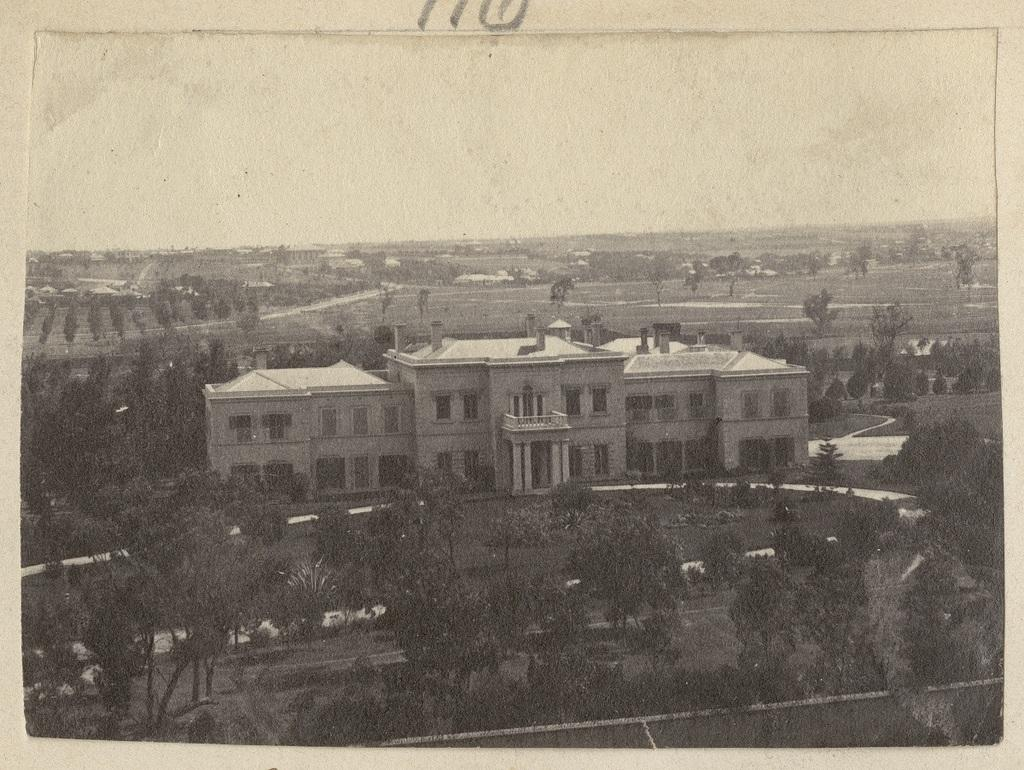What is the main subject of the image? The main subject of the image is a photo of a building. What type of natural elements can be seen in the image? There are trees and grass in the image. What man-made feature is present in the image? There is a road in the image. What part of the natural environment is visible in the image? The sky is visible in the image. How many girls are playing with mice in the image? There are no girls or mice present in the image. What decision is depicted being made in the image? There is no decision-making process depicted in the image; it features a photo of a building, trees, grass, a road, and the sky. 